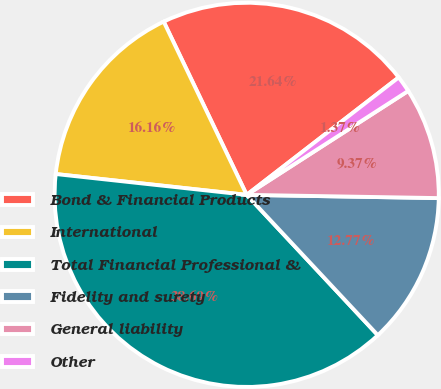<chart> <loc_0><loc_0><loc_500><loc_500><pie_chart><fcel>Bond & Financial Products<fcel>International<fcel>Total Financial Professional &<fcel>Fidelity and surety<fcel>General liability<fcel>Other<nl><fcel>21.64%<fcel>16.16%<fcel>38.69%<fcel>12.77%<fcel>9.37%<fcel>1.37%<nl></chart> 